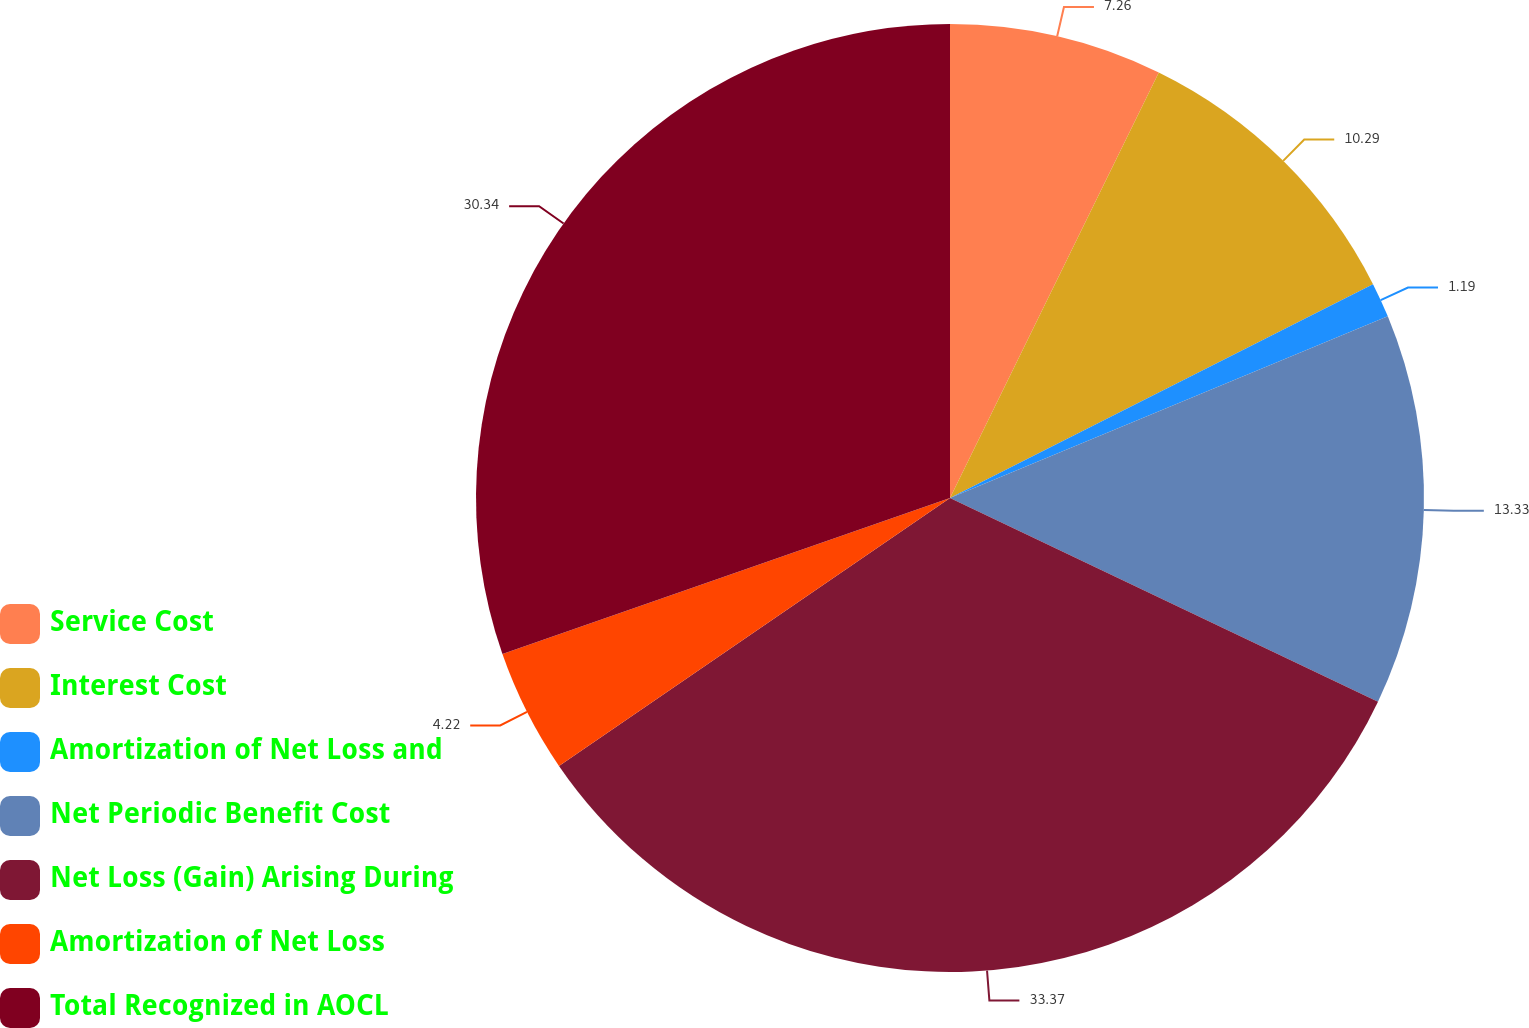Convert chart. <chart><loc_0><loc_0><loc_500><loc_500><pie_chart><fcel>Service Cost<fcel>Interest Cost<fcel>Amortization of Net Loss and<fcel>Net Periodic Benefit Cost<fcel>Net Loss (Gain) Arising During<fcel>Amortization of Net Loss<fcel>Total Recognized in AOCL<nl><fcel>7.26%<fcel>10.29%<fcel>1.19%<fcel>13.33%<fcel>33.37%<fcel>4.22%<fcel>30.34%<nl></chart> 